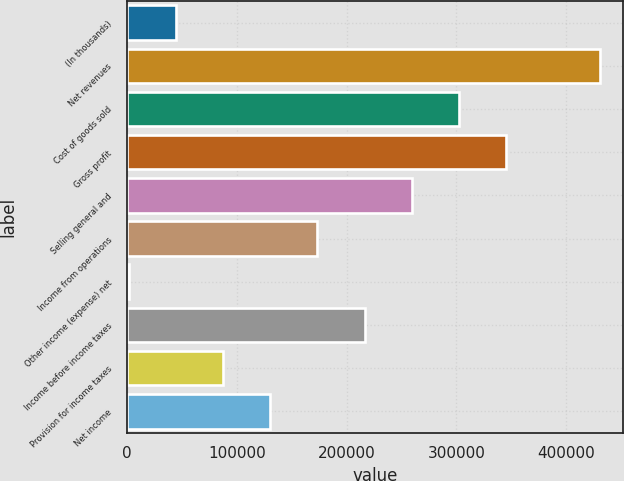Convert chart to OTSL. <chart><loc_0><loc_0><loc_500><loc_500><bar_chart><fcel>(In thousands)<fcel>Net revenues<fcel>Cost of goods sold<fcel>Gross profit<fcel>Selling general and<fcel>Income from operations<fcel>Other income (expense) net<fcel>Income before income taxes<fcel>Provision for income taxes<fcel>Net income<nl><fcel>44697.9<fcel>430689<fcel>302025<fcel>344913<fcel>259137<fcel>173362<fcel>1810<fcel>216250<fcel>87585.8<fcel>130474<nl></chart> 